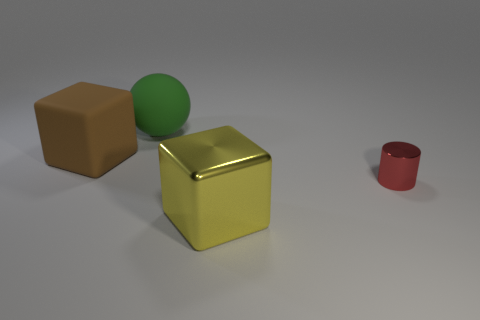Add 4 large brown matte things. How many objects exist? 8 Subtract all cylinders. How many objects are left? 3 Add 4 large green rubber spheres. How many large green rubber spheres exist? 5 Subtract 0 cyan cylinders. How many objects are left? 4 Subtract all purple shiny cylinders. Subtract all metallic things. How many objects are left? 2 Add 1 blocks. How many blocks are left? 3 